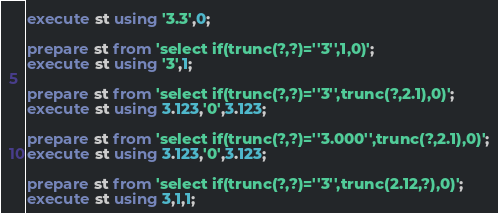<code> <loc_0><loc_0><loc_500><loc_500><_SQL_>execute st using '3.3',0;

prepare st from 'select if(trunc(?,?)=''3'',1,0)';
execute st using '3',1;

prepare st from 'select if(trunc(?,?)=''3'',trunc(?,2.1),0)';
execute st using 3.123,'0',3.123;

prepare st from 'select if(trunc(?,?)=''3.000'',trunc(?,2.1),0)';
execute st using 3.123,'0',3.123;

prepare st from 'select if(trunc(?,?)=''3'',trunc(2.12,?),0)';
execute st using 3,1,1;
</code> 